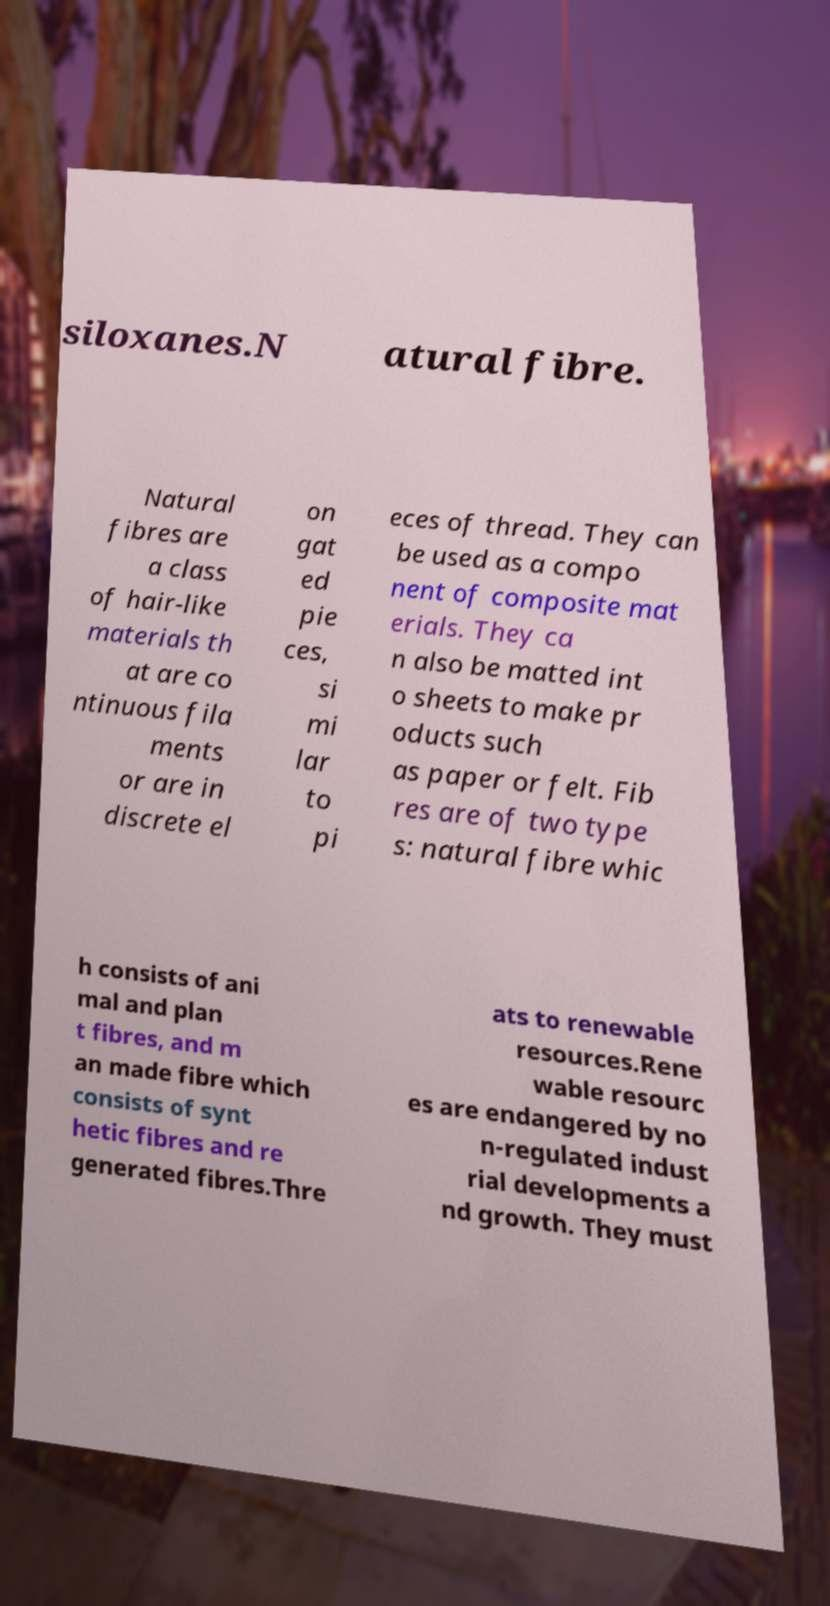Could you extract and type out the text from this image? siloxanes.N atural fibre. Natural fibres are a class of hair-like materials th at are co ntinuous fila ments or are in discrete el on gat ed pie ces, si mi lar to pi eces of thread. They can be used as a compo nent of composite mat erials. They ca n also be matted int o sheets to make pr oducts such as paper or felt. Fib res are of two type s: natural fibre whic h consists of ani mal and plan t fibres, and m an made fibre which consists of synt hetic fibres and re generated fibres.Thre ats to renewable resources.Rene wable resourc es are endangered by no n-regulated indust rial developments a nd growth. They must 